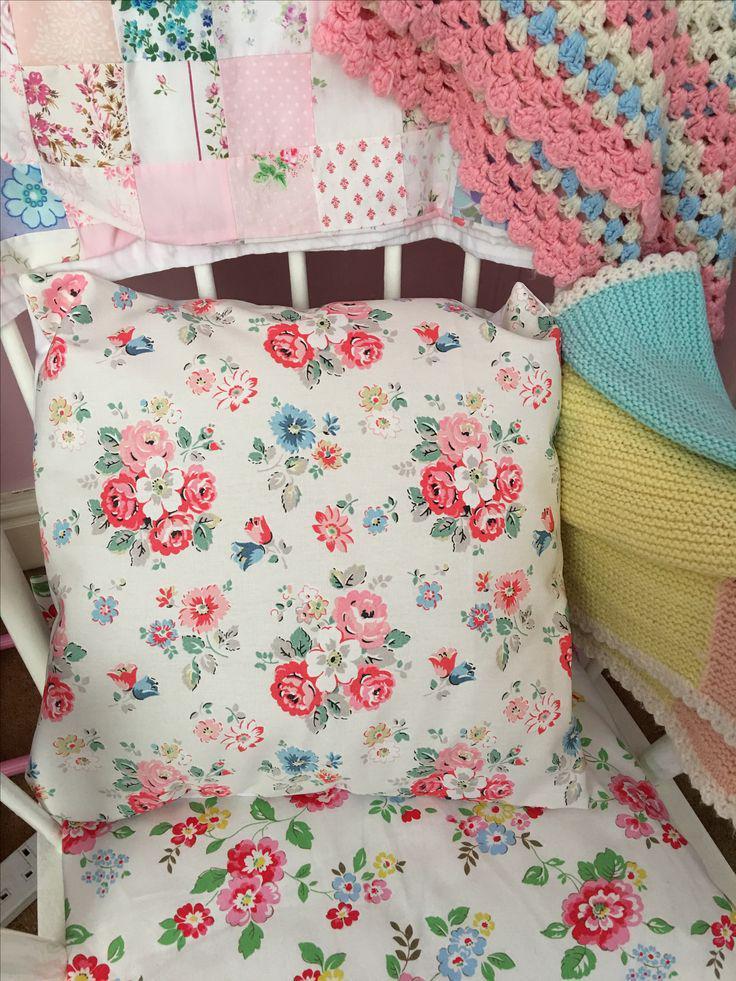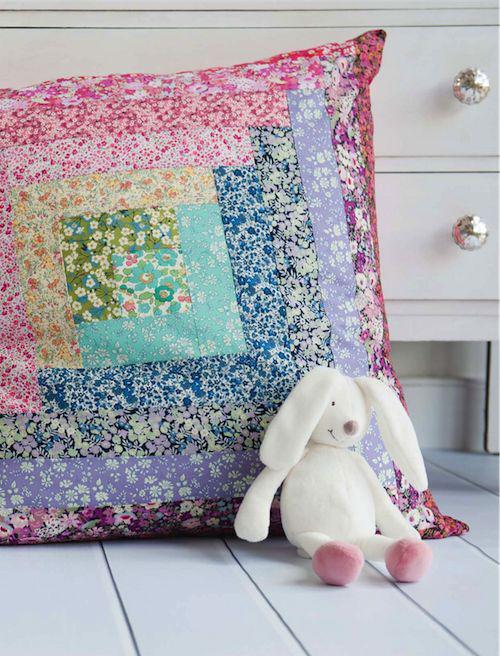The first image is the image on the left, the second image is the image on the right. Evaluate the accuracy of this statement regarding the images: "There are more pillows in the left image than in the right image.". Is it true? Answer yes or no. No. The first image is the image on the left, the second image is the image on the right. Examine the images to the left and right. Is the description "There are there different pillows sitting in a row on top of a cream colored sofa." accurate? Answer yes or no. No. 